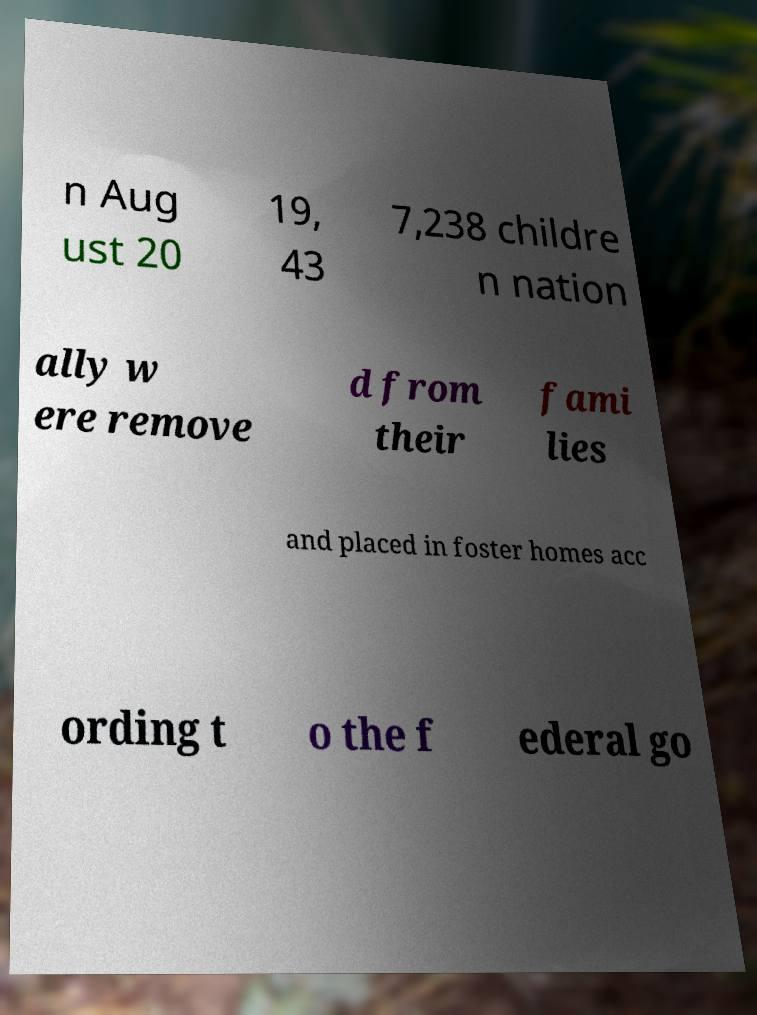For documentation purposes, I need the text within this image transcribed. Could you provide that? n Aug ust 20 19, 43 7,238 childre n nation ally w ere remove d from their fami lies and placed in foster homes acc ording t o the f ederal go 